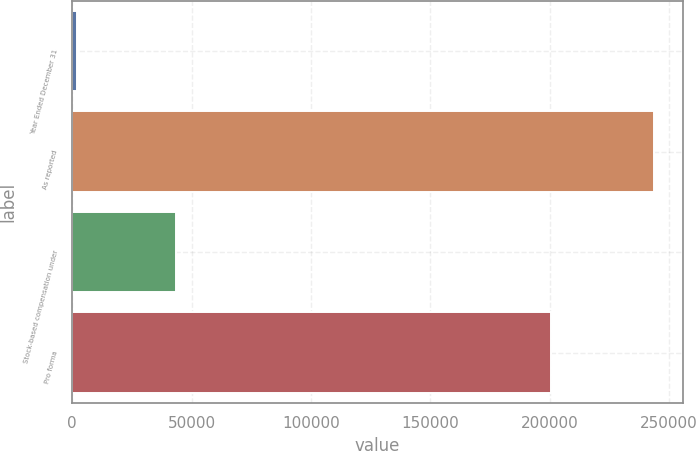Convert chart. <chart><loc_0><loc_0><loc_500><loc_500><bar_chart><fcel>Year Ended December 31<fcel>As reported<fcel>Stock-based compensation under<fcel>Pro forma<nl><fcel>2003<fcel>243697<fcel>43310<fcel>200387<nl></chart> 